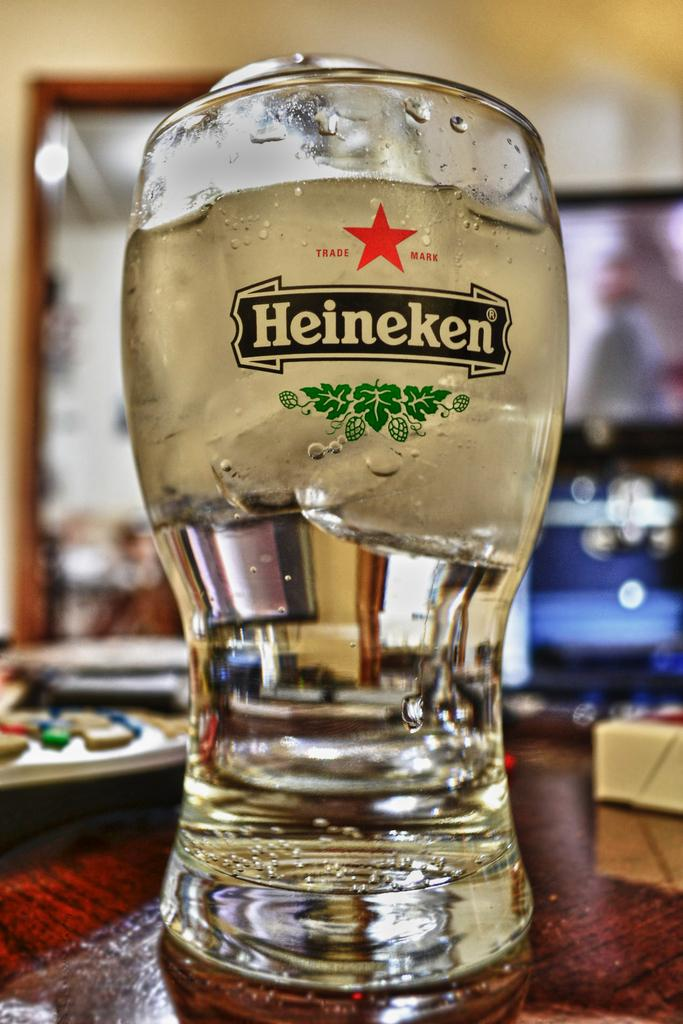What piece of furniture is visible in the image? There is a table in the image. What is on the table? There is a wine glass and a remote on the table, along with other objects. What can be seen in the background of the image? There is a wall and a door in the background of the image. How many clovers are on the table in the image? There are no clovers present in the image. What type of rest is being taken by the objects on the table? The objects on the table are not taking any rest; they are stationary. 